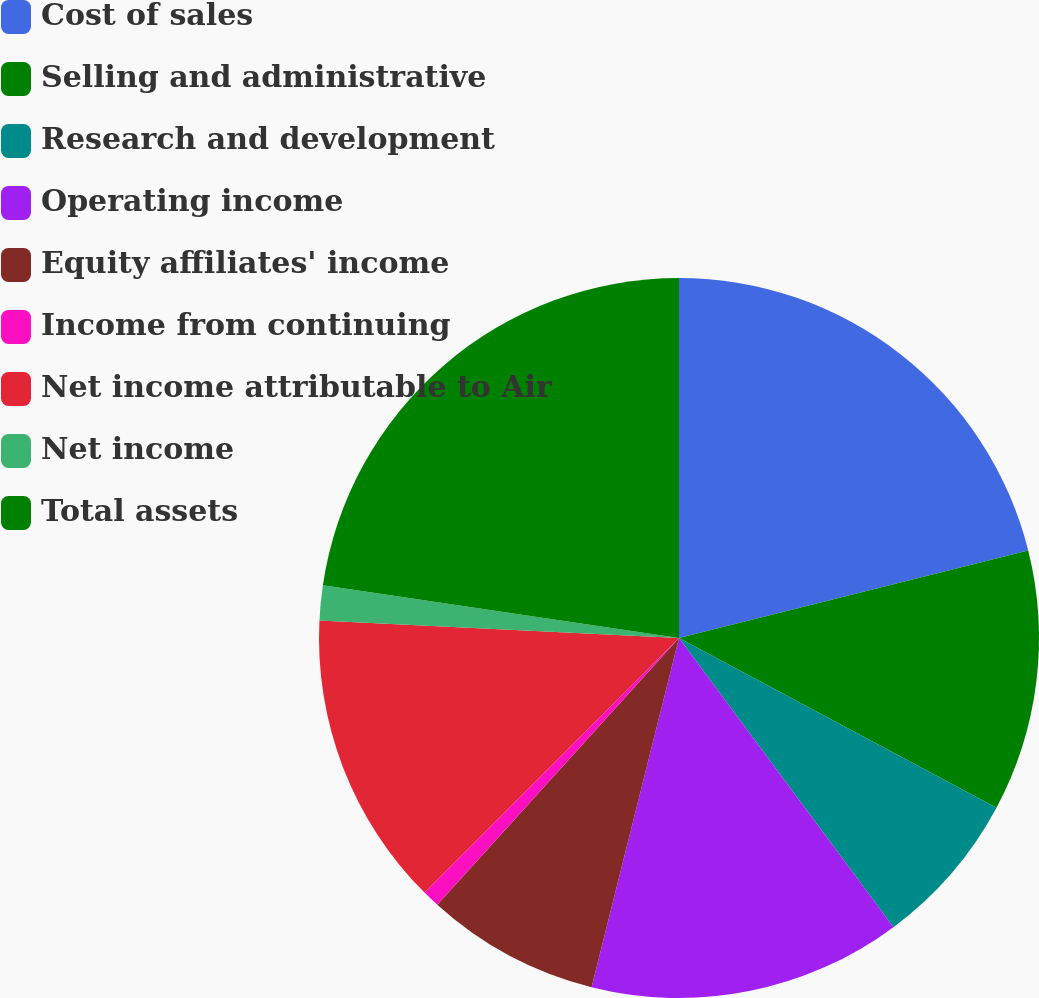Convert chart to OTSL. <chart><loc_0><loc_0><loc_500><loc_500><pie_chart><fcel>Cost of sales<fcel>Selling and administrative<fcel>Research and development<fcel>Operating income<fcel>Equity affiliates' income<fcel>Income from continuing<fcel>Net income attributable to Air<fcel>Net income<fcel>Total assets<nl><fcel>21.09%<fcel>11.72%<fcel>7.03%<fcel>14.06%<fcel>7.81%<fcel>0.78%<fcel>13.28%<fcel>1.56%<fcel>22.66%<nl></chart> 